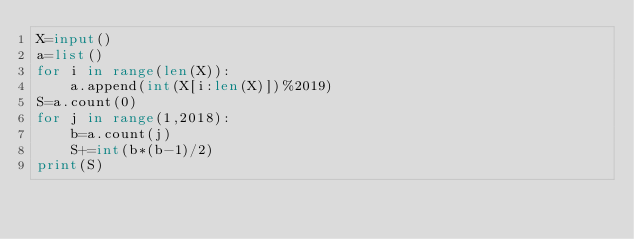Convert code to text. <code><loc_0><loc_0><loc_500><loc_500><_Python_>X=input()
a=list()
for i in range(len(X)):
    a.append(int(X[i:len(X)])%2019)
S=a.count(0)
for j in range(1,2018):
    b=a.count(j)
    S+=int(b*(b-1)/2)
print(S)  
</code> 